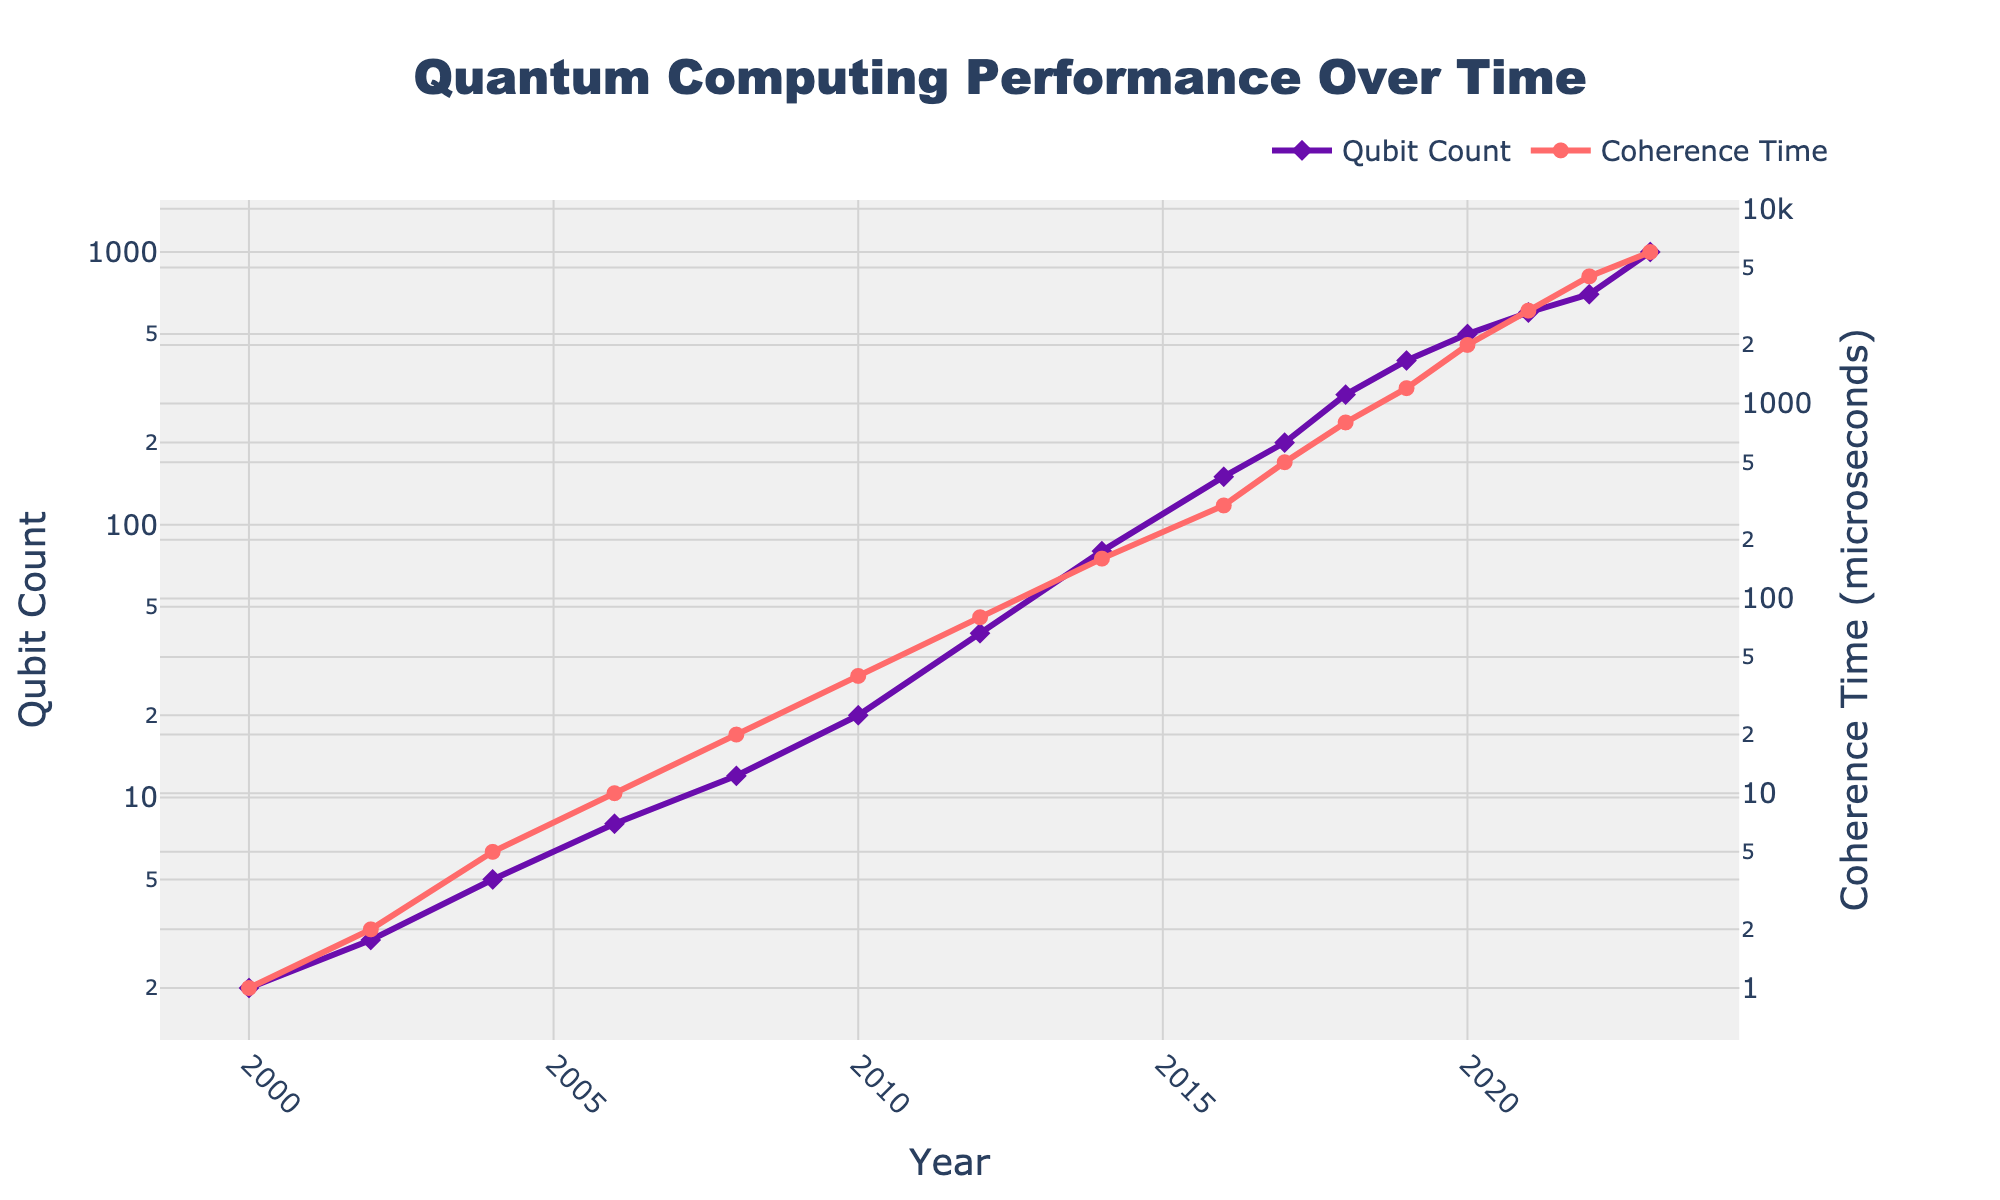How has the Qubit Count changed from 2000 to 2023? In 2000, the Qubit Count is given as 2. By 2023, it has increased to 1000. Examining the difference between these two data points shows substantial growth over the 23 years.
Answer: Increased from 2 to 1000 What is the trend in Coherence Time over the years? By observing the plot, the Coherence Time increases consistently from 1 microsecond in 2000 to 6000 microseconds in 2023, indicating a significant improvement over the years.
Answer: Increasing Which year shows the steepest increase in Qubit Count? We compare the annual increases: from 2000 (2) to 2002 (3), the increase is 1; from 2002 to 2004, 2, and so on. The year 2023 shows the highest increase (700 to 1000), which is 300.
Answer: 2023 Between which years did the Coherence Time surpass 1000 microseconds for the first time? The plot shows Coherence Time surpassing 1000 microseconds between 2019 (1200 microseconds) and 2018 (800 microseconds).
Answer: Between 2018 and 2019 Which data attribute grows faster over time: Qubit Count or Coherence Time? Both attributes show exponential growth, but examining the steepness of the log-scaled lines, Coherence Time has a steeper increase compared to the Qubit Count.
Answer: Coherence Time What is the average annual growth rate of the Qubit Count from 2000 to 2023? Calculate the total increase in Qubit Count (1000 - 2 = 998) and then divide this by the number of years (2023 - 2000 = 23), resulting in an annual rate of 43.39 qubits per year.
Answer: 43.39 qubits/year In what year did both Qubit Count and Coherence Time reach 100 for the first time? For Qubit Count, it reaches 100 around 2014. For Coherence Time, it surpasses 100 in 2014. Therefore, 2014 is the first year both reach 100.
Answer: 2014 What can be inferred about the relationship between the increases in Qubit Count and Coherence Time? Observing the plot, increases in Qubit Count are generally accompanied by increases in Coherence Time over time, suggesting a positive relationship between the two metrics.
Answer: Positive relationship Compare the growth rates of Qubit Count and Coherence Time between 2014 and 2018. Qubit Count in 2014 is 80, and in 2018 it is 300, an increase of 220; Coherence Time in 2014 is 160 and in 2018 it is 800, an increase of 640. Hence, both attributes are growing, but Coherence Time grows more rapidly.
Answer: Coherence Time grows faster What is the ratio of Qubit Count to Coherence Time in 2023? In 2023, the Qubit Count is 1000, and Coherence Time is 6000. The ratio is 1000/6000, which reduces to 1:6.
Answer: 1:6 